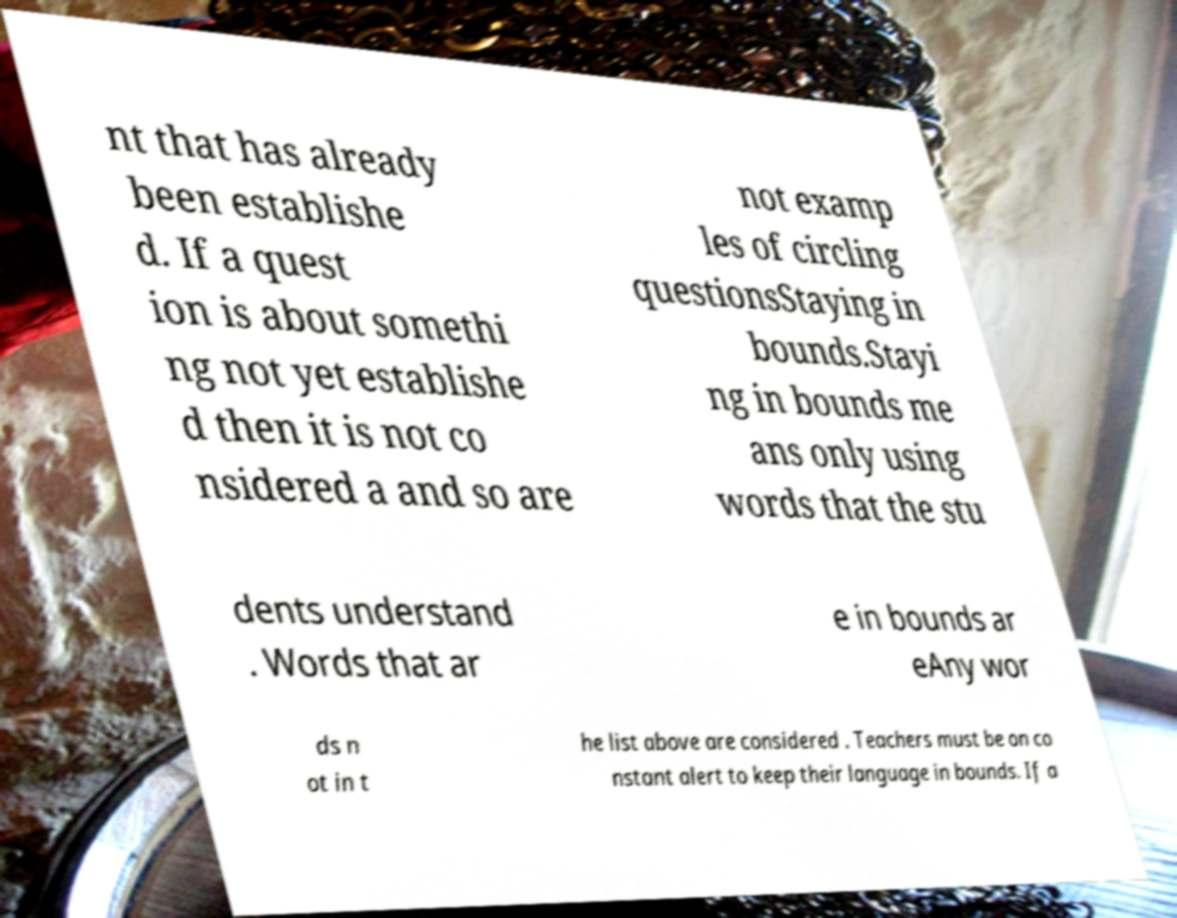There's text embedded in this image that I need extracted. Can you transcribe it verbatim? nt that has already been establishe d. If a quest ion is about somethi ng not yet establishe d then it is not co nsidered a and so are not examp les of circling questionsStaying in bounds.Stayi ng in bounds me ans only using words that the stu dents understand . Words that ar e in bounds ar eAny wor ds n ot in t he list above are considered . Teachers must be on co nstant alert to keep their language in bounds. If a 